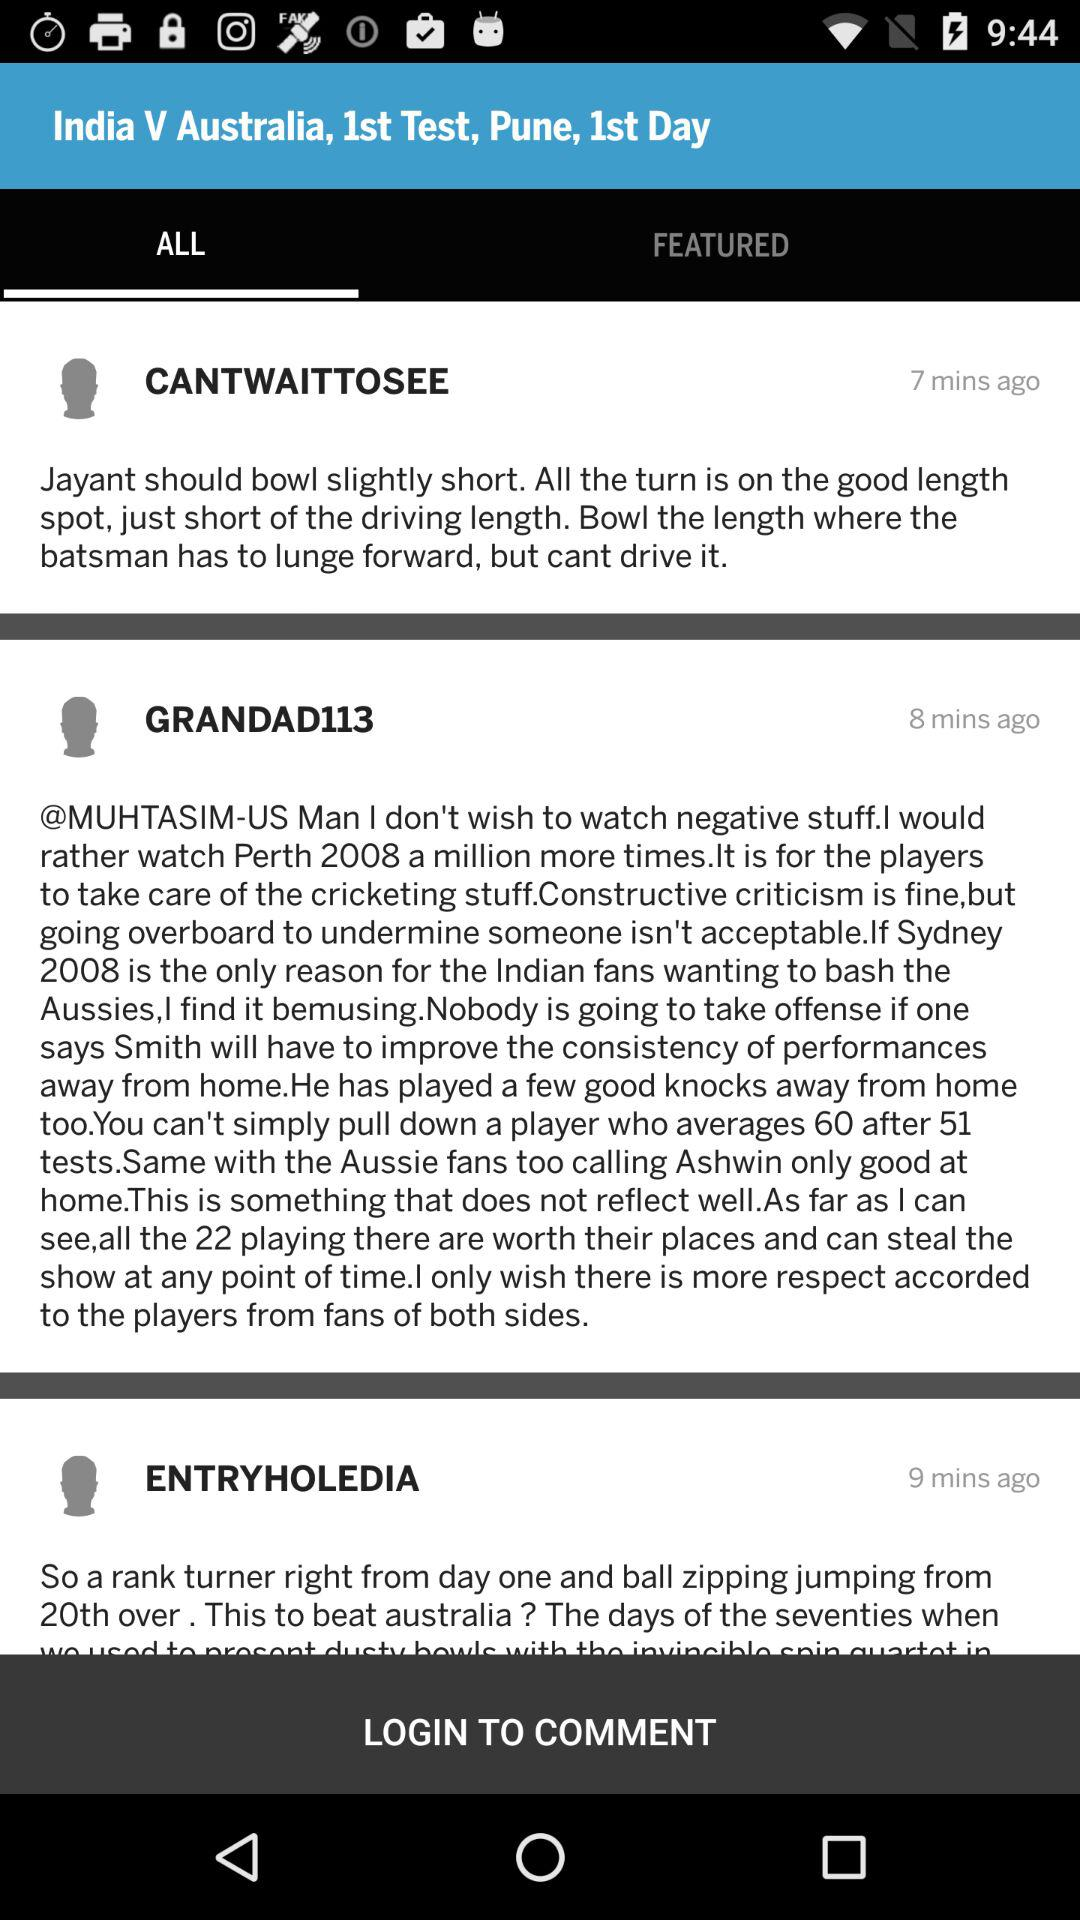How many comments are there in total?
Answer the question using a single word or phrase. 3 